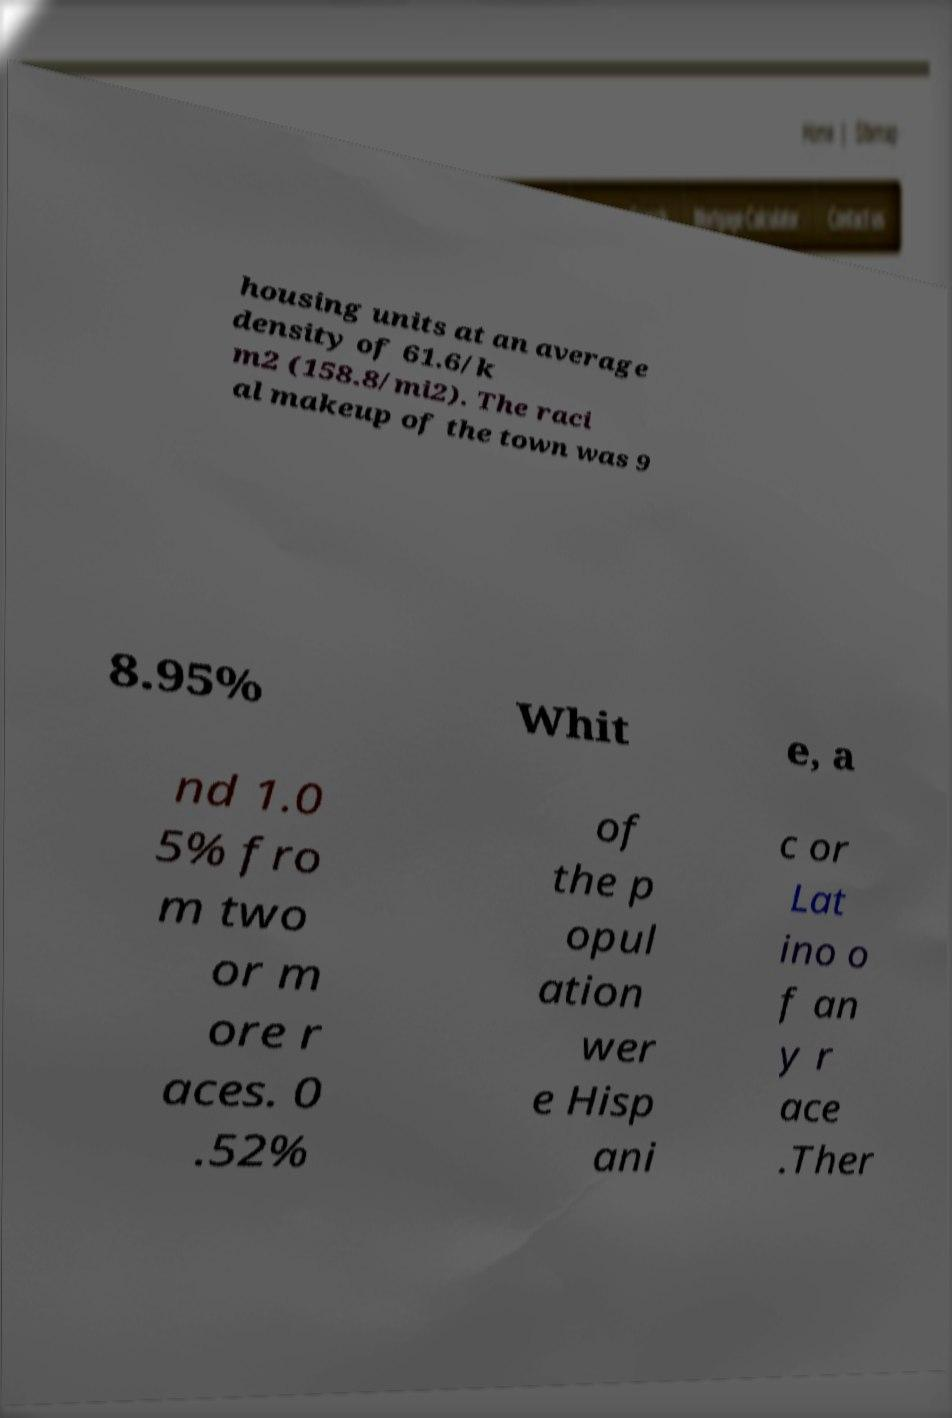Can you read and provide the text displayed in the image?This photo seems to have some interesting text. Can you extract and type it out for me? housing units at an average density of 61.6/k m2 (158.8/mi2). The raci al makeup of the town was 9 8.95% Whit e, a nd 1.0 5% fro m two or m ore r aces. 0 .52% of the p opul ation wer e Hisp ani c or Lat ino o f an y r ace .Ther 